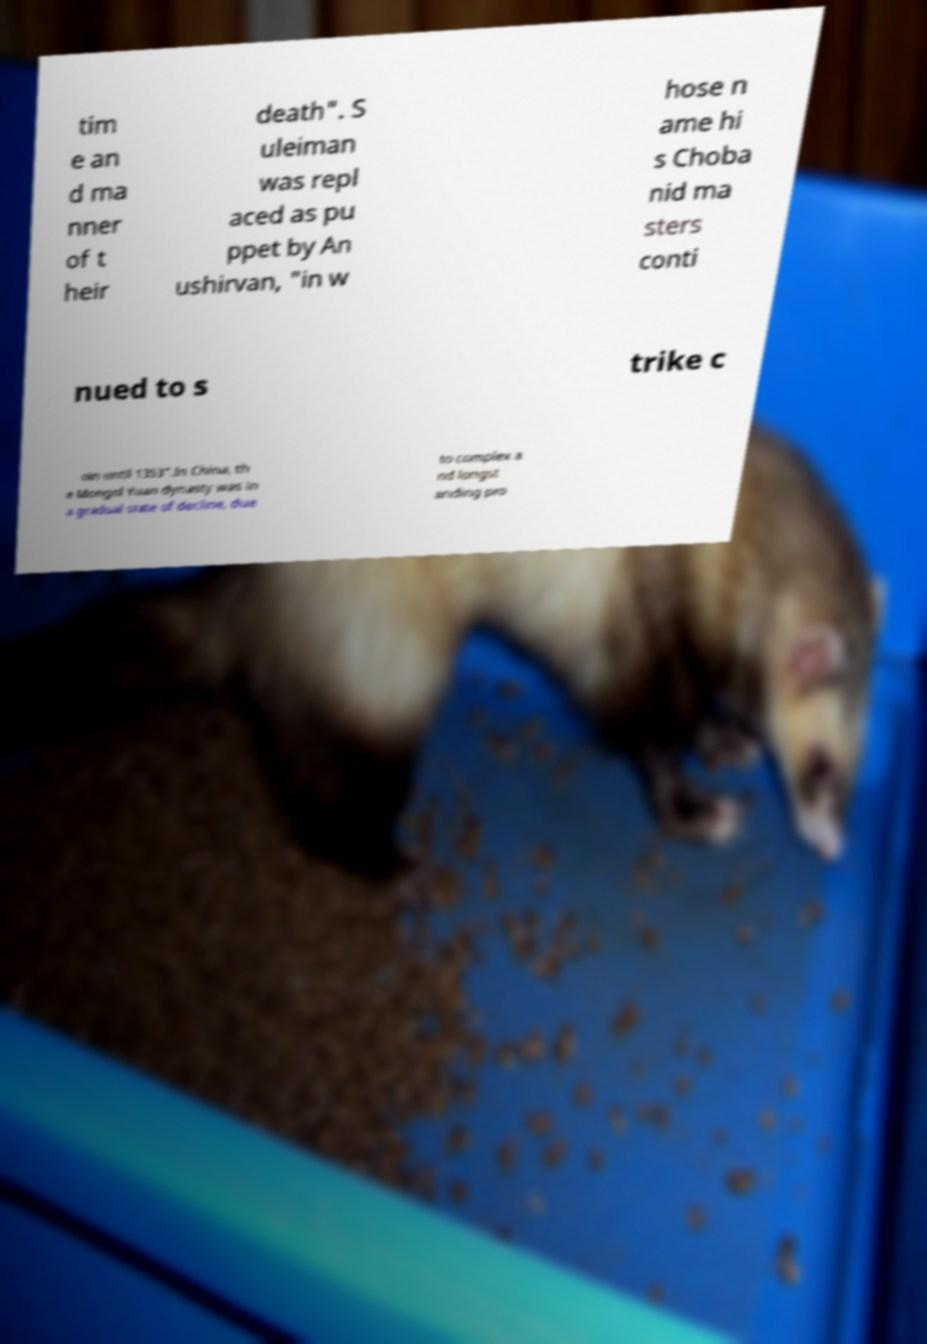Please read and relay the text visible in this image. What does it say? tim e an d ma nner of t heir death". S uleiman was repl aced as pu ppet by An ushirvan, "in w hose n ame hi s Choba nid ma sters conti nued to s trike c oin until 1353".In China, th e Mongol Yuan dynasty was in a gradual state of decline, due to complex a nd longst anding pro 